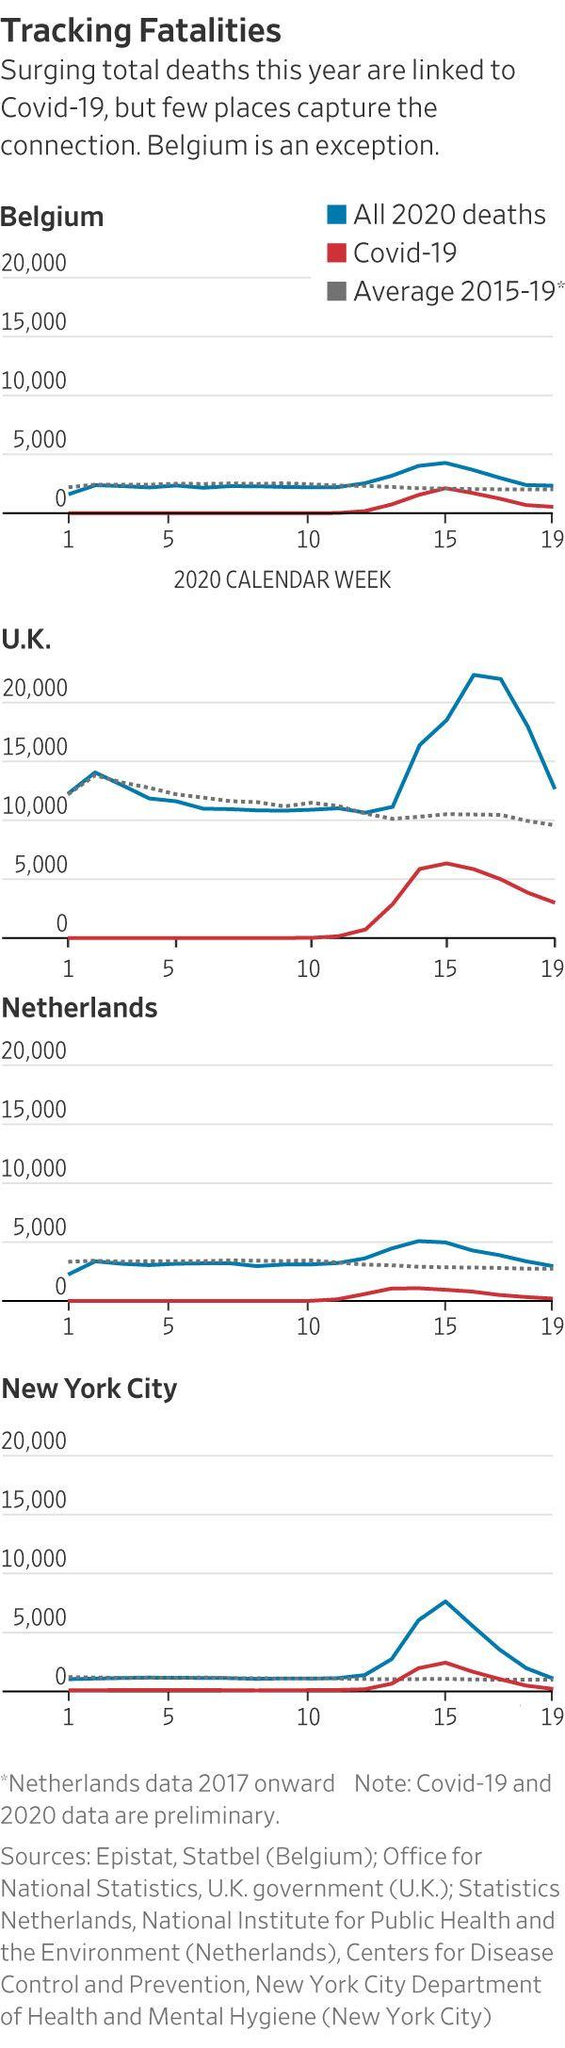Outline some significant characteristics in this image. It has been determined that the color representing COVID-19 deaths is red, not blue. The United Kingdom has surpassed 20,000 deaths due to COVID-19. It is blue that represents all the deaths that occurred in 2020. The COVID-19 death rate was at the same level as the average death rate from 2015 to 2019 in the 15th week. 